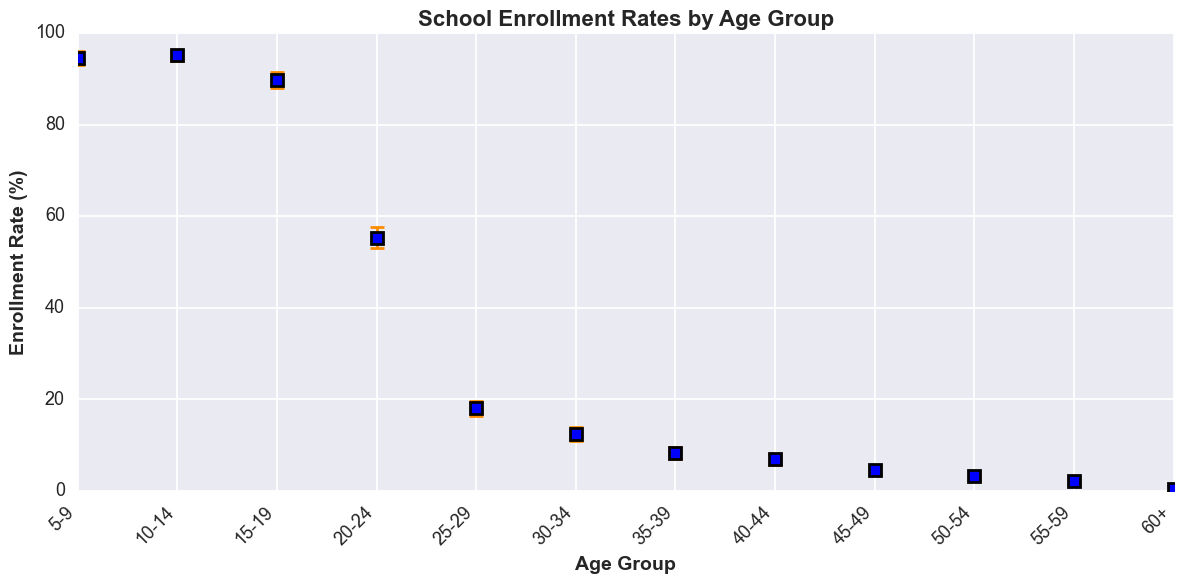What is the enrollment rate for the age group 10-14? The enrollment rate for the age group 10-14 can be directly read from the plot.
Answer: 95.2% Which age group has the highest enrollment rate? The highest point on the y-axis has the enrollment rate with the corresponding age group being the one with the highest rate.
Answer: 10-14 What is the difference in enrollment rates between the 15-19 and 20-24 age groups? Subtract the enrollment rate of the 20-24 age group from the 15-19 age group: 89.8% - 55.3% = 34.5%
Answer: 34.5% Which age group has the smallest confidence interval range? Calculate the difference between the upper and lower confidence intervals for each age group and find the smallest: 10-14 age group's range is 96.4% - 94.0% = 2.4%
Answer: 10-14 For which age groups is the enrollment rate less than 10%? Identify age groups with enrollment rates on the plot below 10%.
Answer: 35-39, 40-44, 45-49, 50-54, 55-59, 60+ Between which two consecutive age groups is the largest drop in enrollment rate? Find the largest difference between enrollment rates of consecutive age groups by subtracting rates and comparing them. The largest drop is between 15-19 and 20-24: 89.8% - 55.3% = 34.5%
Answer: 15-19 and 20-24 What is the average enrollment rate for the age groups from 5-9 to 15-19? Add the enrollment rates for the age groups 5-9, 10-14, and 15-19, then divide by the number of groups: (94.5 + 95.2 + 89.8) / 3 = 93.1667%
Answer: 93.2% Which age group has the broadest confidence interval range? Subtract the lower confidence interval from the upper confidence interval for each age group, then find the largest result: 25-29 age group's range is 19.7% - 16.5% = 3.2%
Answer: 25-29 